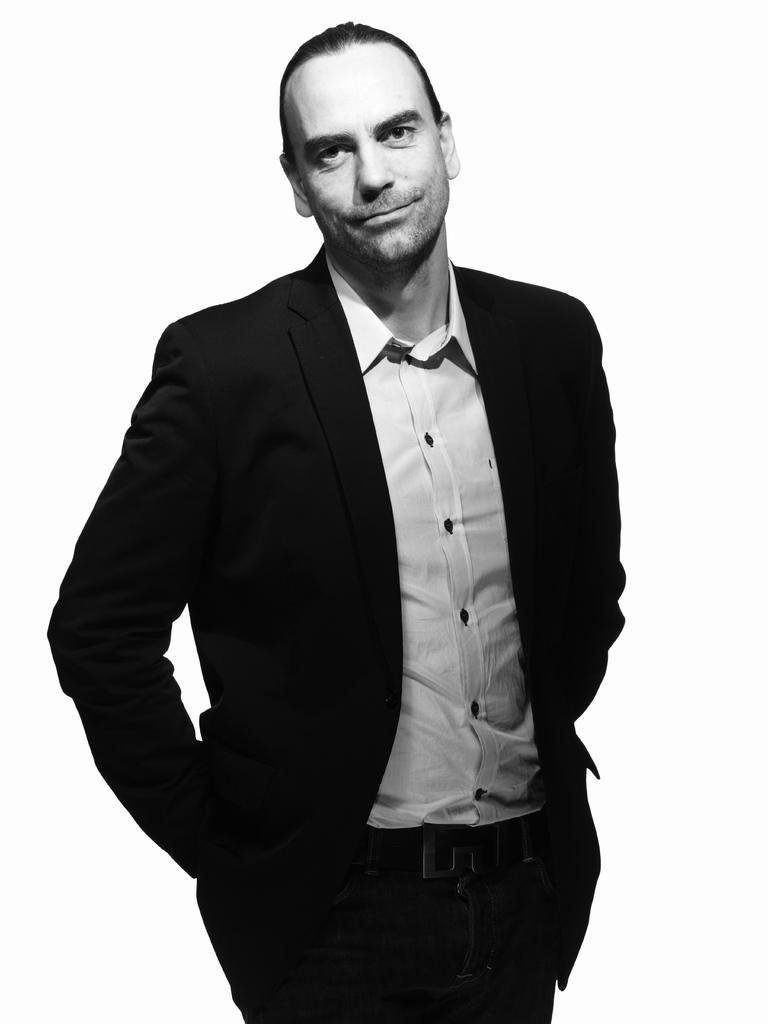Could you give a brief overview of what you see in this image? In this picture I can see a man and a white color background. 